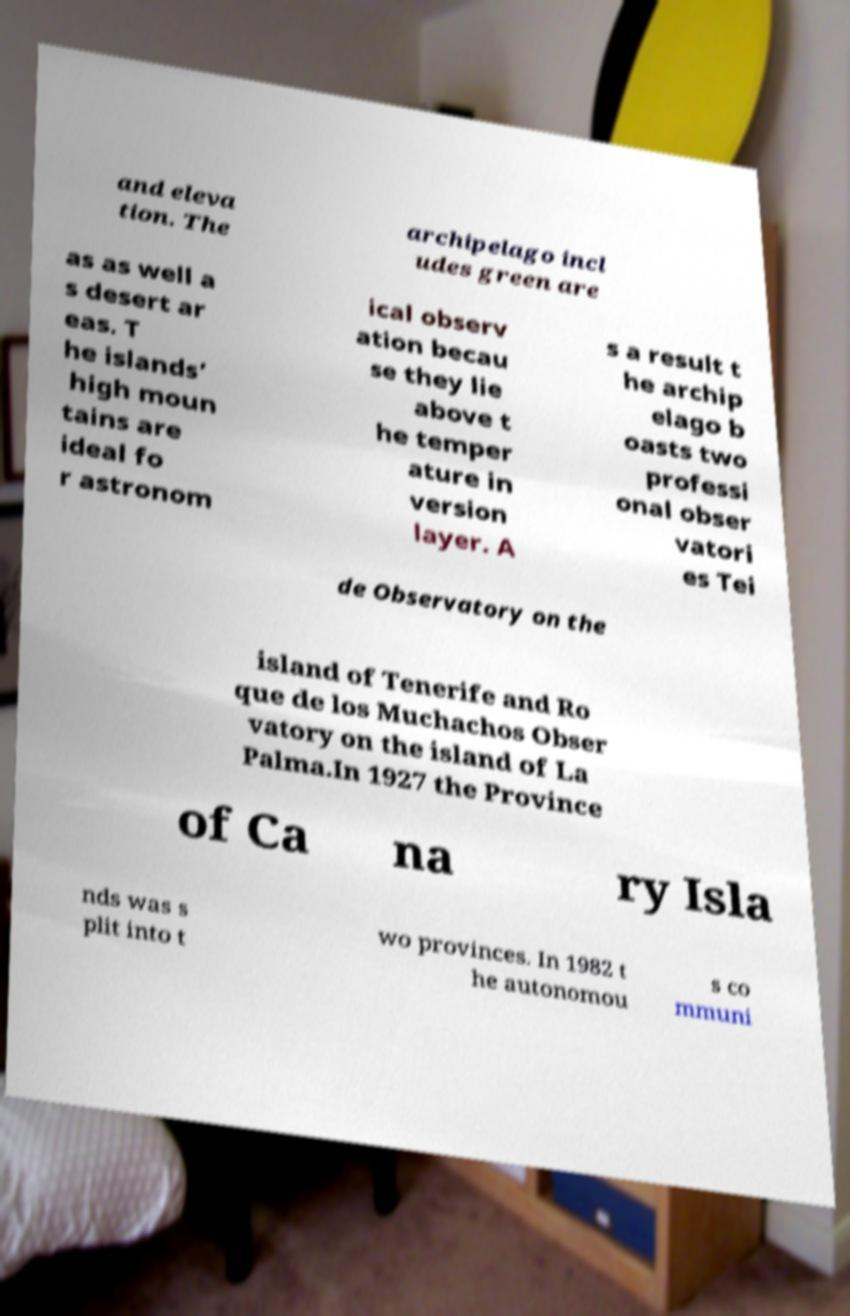There's text embedded in this image that I need extracted. Can you transcribe it verbatim? and eleva tion. The archipelago incl udes green are as as well a s desert ar eas. T he islands’ high moun tains are ideal fo r astronom ical observ ation becau se they lie above t he temper ature in version layer. A s a result t he archip elago b oasts two professi onal obser vatori es Tei de Observatory on the island of Tenerife and Ro que de los Muchachos Obser vatory on the island of La Palma.In 1927 the Province of Ca na ry Isla nds was s plit into t wo provinces. In 1982 t he autonomou s co mmuni 